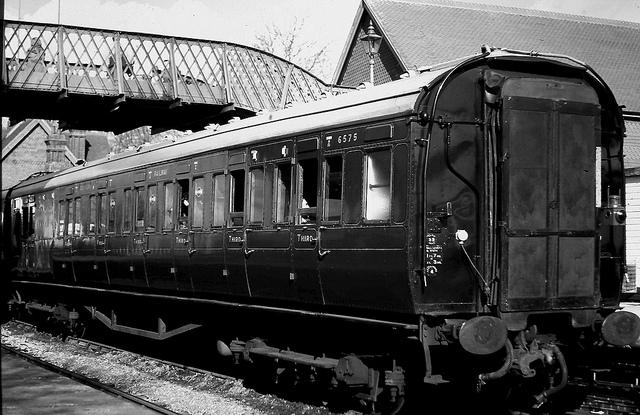What two numbers are repeated in the sequence on the back of the train?
Short answer required. 6575. Is this a black and white picture?
Quick response, please. Yes. Is anyone looking out of the window?
Keep it brief. No. What number is on the train?
Concise answer only. 6575. Is this train usable today?
Short answer required. No. 